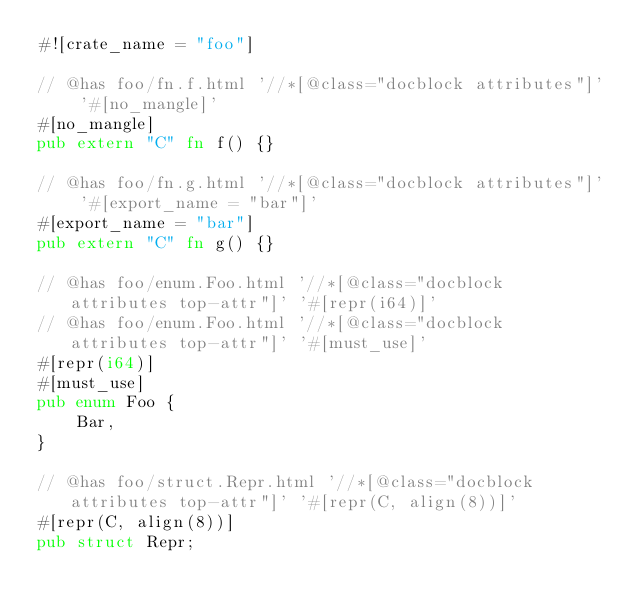Convert code to text. <code><loc_0><loc_0><loc_500><loc_500><_Rust_>#![crate_name = "foo"]

// @has foo/fn.f.html '//*[@class="docblock attributes"]' '#[no_mangle]'
#[no_mangle]
pub extern "C" fn f() {}

// @has foo/fn.g.html '//*[@class="docblock attributes"]' '#[export_name = "bar"]'
#[export_name = "bar"]
pub extern "C" fn g() {}

// @has foo/enum.Foo.html '//*[@class="docblock attributes top-attr"]' '#[repr(i64)]'
// @has foo/enum.Foo.html '//*[@class="docblock attributes top-attr"]' '#[must_use]'
#[repr(i64)]
#[must_use]
pub enum Foo {
    Bar,
}

// @has foo/struct.Repr.html '//*[@class="docblock attributes top-attr"]' '#[repr(C, align(8))]'
#[repr(C, align(8))]
pub struct Repr;
</code> 